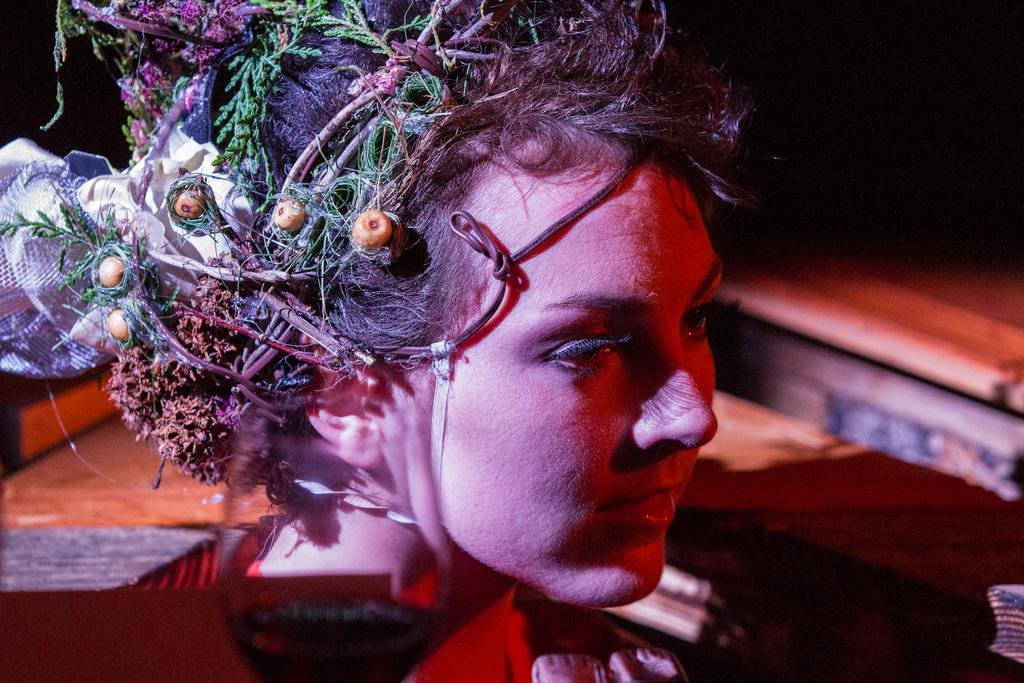Who is the main subject in the image? There is a woman in the image. What is on the woman's head? There are leaves on the woman's head. How would you describe the background of the image? The background of the image is dark. What type of fang can be seen in the woman's hand in the image? There is no fang present in the image, and the woman's hands are not visible. 